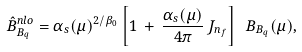Convert formula to latex. <formula><loc_0><loc_0><loc_500><loc_500>\hat { B } _ { B _ { q } } ^ { n l o } = \alpha _ { s } ( \mu ) ^ { 2 / \beta _ { 0 } } \left [ 1 \, + \, \frac { \alpha _ { s } ( \mu ) } { 4 \pi } \, J _ { n _ { f } } \right ] \ B _ { B _ { q } } ( \mu ) ,</formula> 